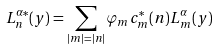Convert formula to latex. <formula><loc_0><loc_0><loc_500><loc_500>L ^ { \alpha * } _ { n } ( y ) = \sum _ { | m | = | n | } \varphi _ { m } c ^ { * } _ { m } ( n ) L _ { m } ^ { \alpha } ( y )</formula> 